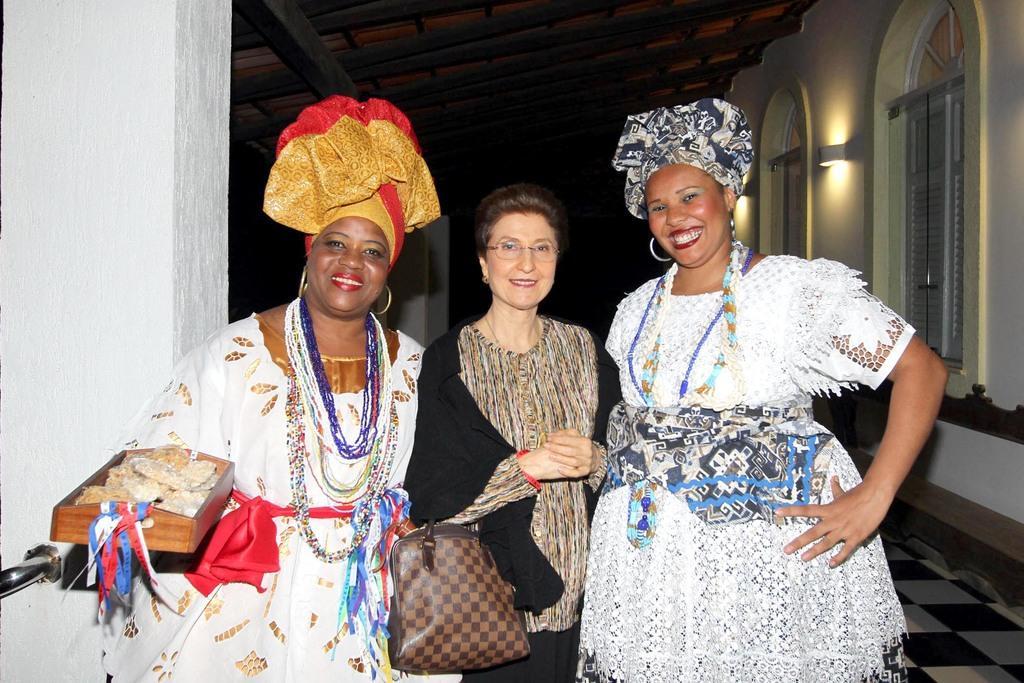In one or two sentences, can you explain what this image depicts? This picture shows three women standing with a smile on their faces and a woman holds a handbag in her hand 